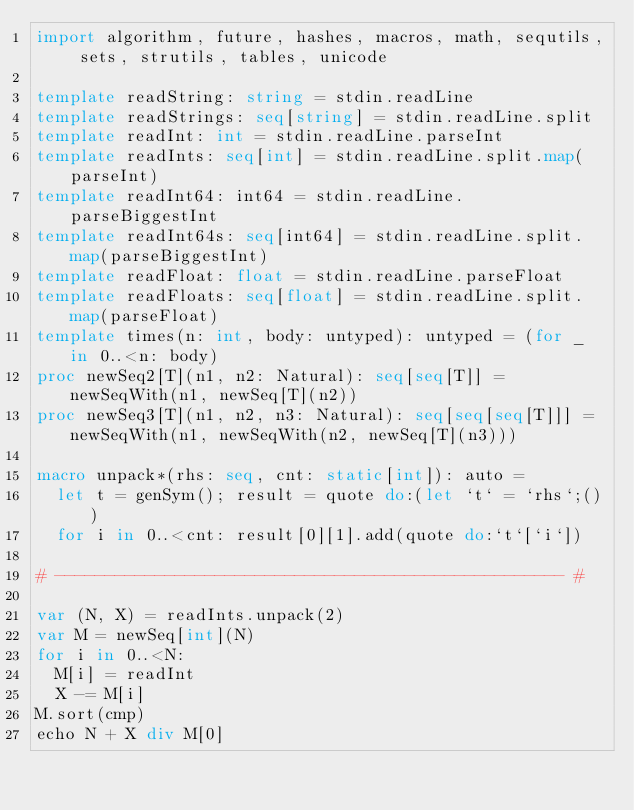<code> <loc_0><loc_0><loc_500><loc_500><_Nim_>import algorithm, future, hashes, macros, math, sequtils, sets, strutils, tables, unicode

template readString: string = stdin.readLine
template readStrings: seq[string] = stdin.readLine.split
template readInt: int = stdin.readLine.parseInt
template readInts: seq[int] = stdin.readLine.split.map(parseInt)
template readInt64: int64 = stdin.readLine.parseBiggestInt
template readInt64s: seq[int64] = stdin.readLine.split.map(parseBiggestInt)
template readFloat: float = stdin.readLine.parseFloat
template readFloats: seq[float] = stdin.readLine.split.map(parseFloat)
template times(n: int, body: untyped): untyped = (for _ in 0..<n: body)
proc newSeq2[T](n1, n2: Natural): seq[seq[T]] = newSeqWith(n1, newSeq[T](n2))
proc newSeq3[T](n1, n2, n3: Natural): seq[seq[seq[T]]] = newSeqWith(n1, newSeqWith(n2, newSeq[T](n3)))

macro unpack*(rhs: seq, cnt: static[int]): auto =
  let t = genSym(); result = quote do:(let `t` = `rhs`;())
  for i in 0..<cnt: result[0][1].add(quote do:`t`[`i`])

# --------------------------------------------------- #

var (N, X) = readInts.unpack(2)
var M = newSeq[int](N)
for i in 0..<N:
  M[i] = readInt
  X -= M[i]
M.sort(cmp)
echo N + X div M[0]
</code> 